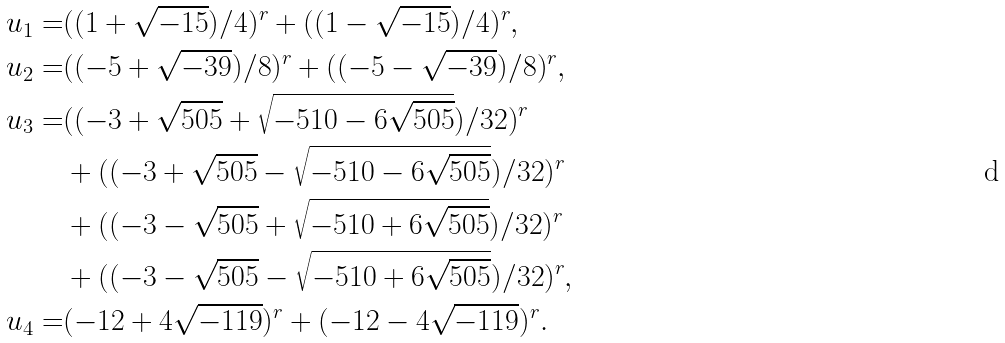Convert formula to latex. <formula><loc_0><loc_0><loc_500><loc_500>u _ { 1 } = & ( ( 1 + \sqrt { - 1 5 } ) / 4 ) ^ { r } + ( ( 1 - \sqrt { - 1 5 } ) / 4 ) ^ { r } , \\ u _ { 2 } = & ( ( - 5 + \sqrt { - 3 9 } ) / 8 ) ^ { r } + ( ( - 5 - \sqrt { - 3 9 } ) / 8 ) ^ { r } , \\ u _ { 3 } = & ( ( - 3 + \sqrt { 5 0 5 } + \sqrt { - 5 1 0 - 6 \sqrt { 5 0 5 } } ) / 3 2 ) ^ { r } \\ & + ( ( - 3 + \sqrt { 5 0 5 } - \sqrt { { - 5 1 0 - 6 \sqrt { 5 0 5 } } } ) / 3 2 ) ^ { r } \\ & + ( ( - 3 - \sqrt { 5 0 5 } + \sqrt { - 5 1 0 + 6 \sqrt { 5 0 5 } } ) / 3 2 ) ^ { r } \\ & + ( ( - 3 - \sqrt { 5 0 5 } - \sqrt { - 5 1 0 + 6 \sqrt { 5 0 5 } } ) / 3 2 ) ^ { r } , \\ u _ { 4 } = & ( - 1 2 + 4 \sqrt { - 1 1 9 } ) ^ { r } + ( - 1 2 - 4 \sqrt { - 1 1 9 } ) ^ { r } . \\</formula> 